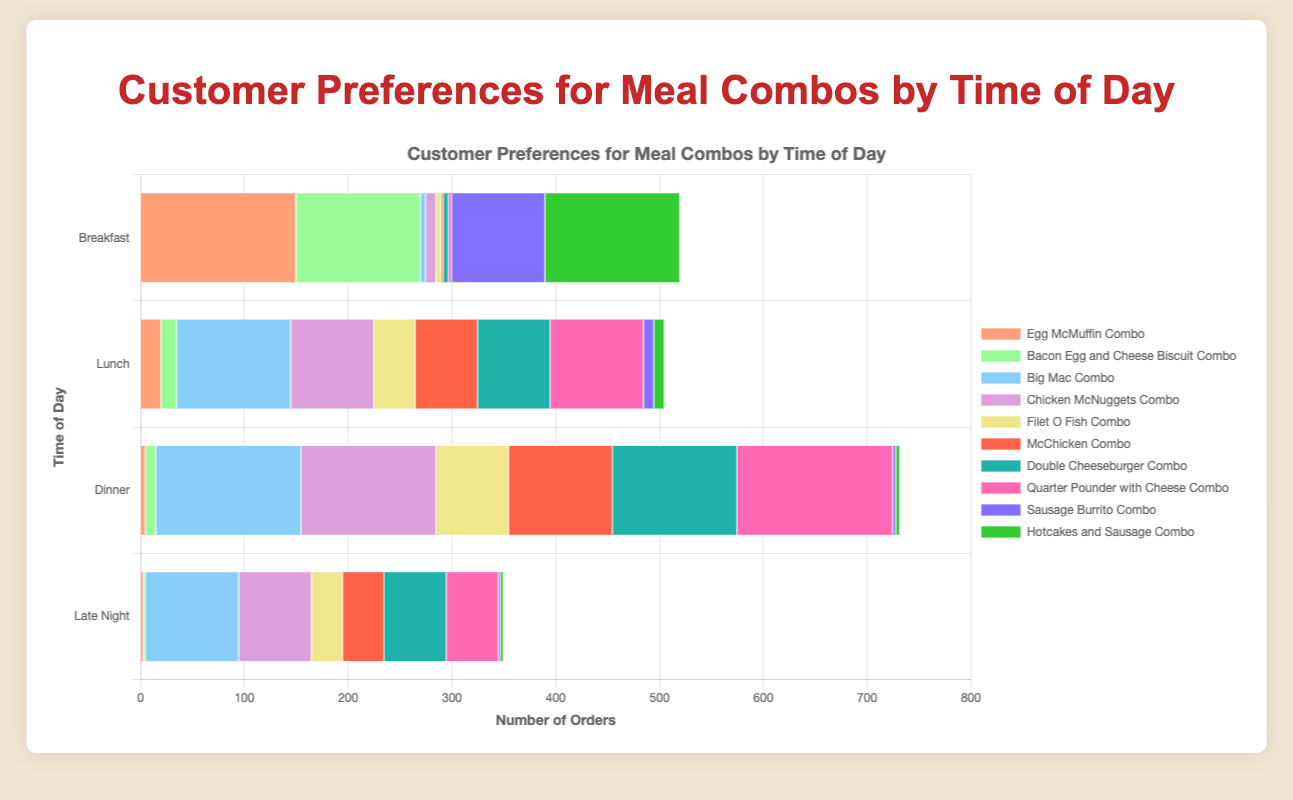Which meal combo is the most preferred during Breakfast? By observing the chart, the Egg McMuffin Combo has the highest bar segment in the Breakfast category.
Answer: Egg McMuffin Combo How many orders of Big Mac Combo are there during Lunch and Dinner combined? Referring to the chart, the Big Mac Combo orders during Lunch are 110 and during Dinner are 140. Summing these values gives 110 + 140 = 250.
Answer: 250 Which time of day sees the highest number of Double Cheeseburger Combo orders? Look at the bar segments for Double Cheeseburger Combo across all times. The Dinner segment is the tallest, indicating the highest orders.
Answer: Dinner Is the number of orders for Chicken McNuggets Combo during Late Night greater than the combined orders for McChicken Combo and Hotcakes and Sausage Combo during Breakfast? Late Night orders for Chicken McNuggets Combo are 70. For Breakfast, McChicken Combo has 2 orders, and Hotcakes and Sausage Combo has 130 orders. Their sum is 2 + 130 = 132, which is greater than 70.
Answer: No What is the total number of orders for Sausage Burrito Combo across all times of day? Add the numbers for Sausage Burrito Combo from Breakfast, Lunch, Dinner, and Late Night: 90 + 10 + 3 + 2 = 105.
Answer: 105 During which time of day are the most varied meal combos ordered, based on the number of total meals shown in the chart? Examine the combined heights of all bar segments across each time of day. Dinner has the tallest stacked bars summing across all meal combos.
Answer: Dinner Which combo has a higher preference during Lunch: Filet O Fish Combo or Quarter Pounder with Cheese Combo? The length of the bar segment for Quarter Pounder with Cheese Combo during Lunch is longer (90) than that for Filet O Fish Combo (40).
Answer: Quarter Pounder with Cheese Combo What is the difference in orders for Hotcakes and Sausage Combo between Breakfast and Dinner? Breakfast has 130 orders and Dinner has 4 orders for Hotcakes and Sausage Combo. The difference is 130 - 4 = 126.
Answer: 126 During Late Night, which meal combos have fewer than 10 orders? Observe the Late Night bar segments: the Egg McMuffin Combo (3), Bacon Egg and Cheese Biscuit Combo (2), Sausage Burrito Combo (2), and Hotcakes and Sausage Combo (3) are all fewer than 10 orders.
Answer: Egg McMuffin Combo, Bacon Egg and Cheese Biscuit Combo, Sausage Burrito Combo, Hotcakes and Sausage Combo 